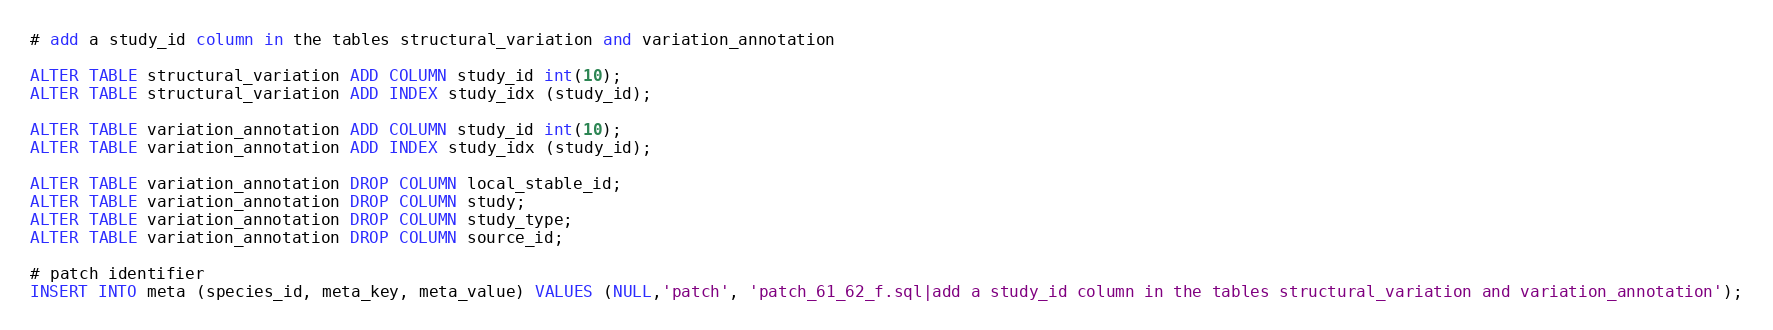Convert code to text. <code><loc_0><loc_0><loc_500><loc_500><_SQL_>

# add a study_id column in the tables structural_variation and variation_annotation

ALTER TABLE structural_variation ADD COLUMN study_id int(10);
ALTER TABLE structural_variation ADD INDEX study_idx (study_id);

ALTER TABLE variation_annotation ADD COLUMN study_id int(10);
ALTER TABLE variation_annotation ADD INDEX study_idx (study_id);

ALTER TABLE variation_annotation DROP COLUMN local_stable_id;
ALTER TABLE variation_annotation DROP COLUMN study;
ALTER TABLE variation_annotation DROP COLUMN study_type;
ALTER TABLE variation_annotation DROP COLUMN source_id;

# patch identifier
INSERT INTO meta (species_id, meta_key, meta_value) VALUES (NULL,'patch', 'patch_61_62_f.sql|add a study_id column in the tables structural_variation and variation_annotation');
</code> 